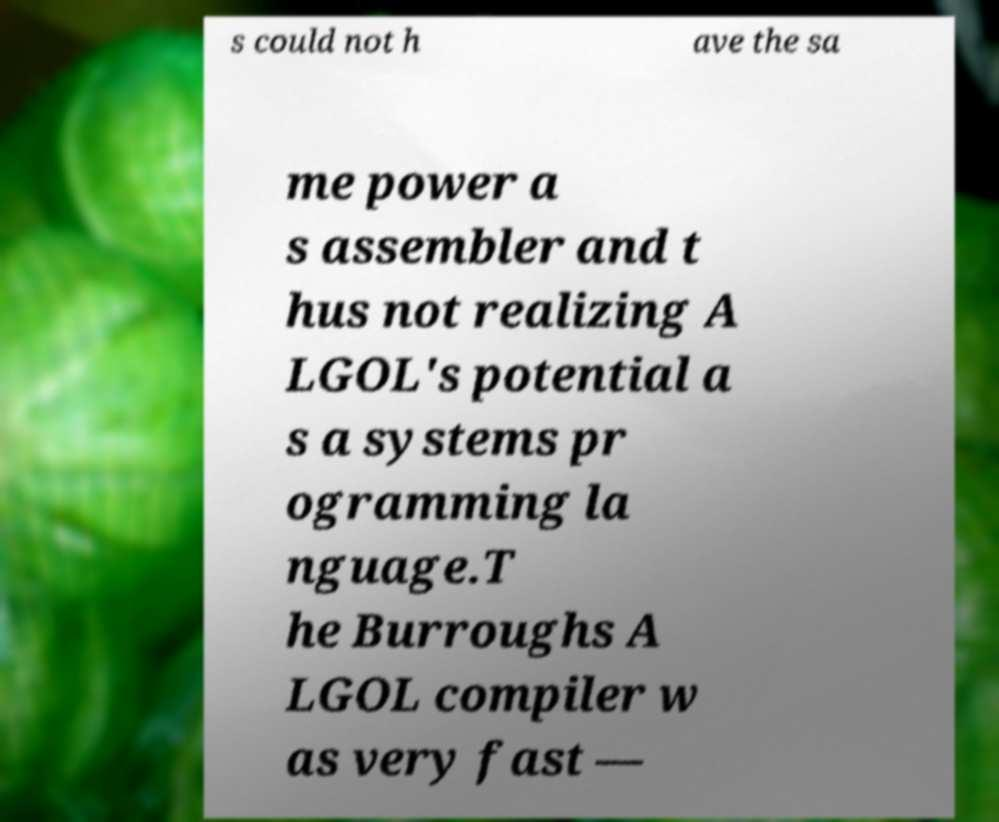Could you assist in decoding the text presented in this image and type it out clearly? s could not h ave the sa me power a s assembler and t hus not realizing A LGOL's potential a s a systems pr ogramming la nguage.T he Burroughs A LGOL compiler w as very fast — 